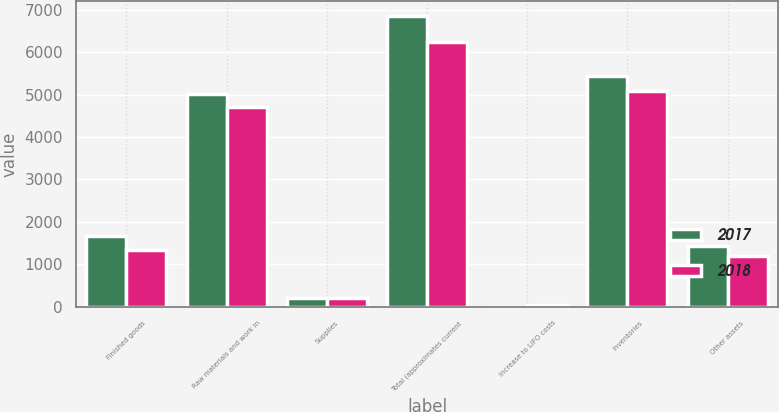Convert chart. <chart><loc_0><loc_0><loc_500><loc_500><stacked_bar_chart><ecel><fcel>Finished goods<fcel>Raw materials and work in<fcel>Supplies<fcel>Total (approximates current<fcel>Increase to LIFO costs<fcel>Inventories<fcel>Other assets<nl><fcel>2017<fcel>1658<fcel>5004<fcel>194<fcel>6856<fcel>1<fcel>5440<fcel>1417<nl><fcel>2018<fcel>1334<fcel>4703<fcel>201<fcel>6238<fcel>45<fcel>5096<fcel>1187<nl></chart> 